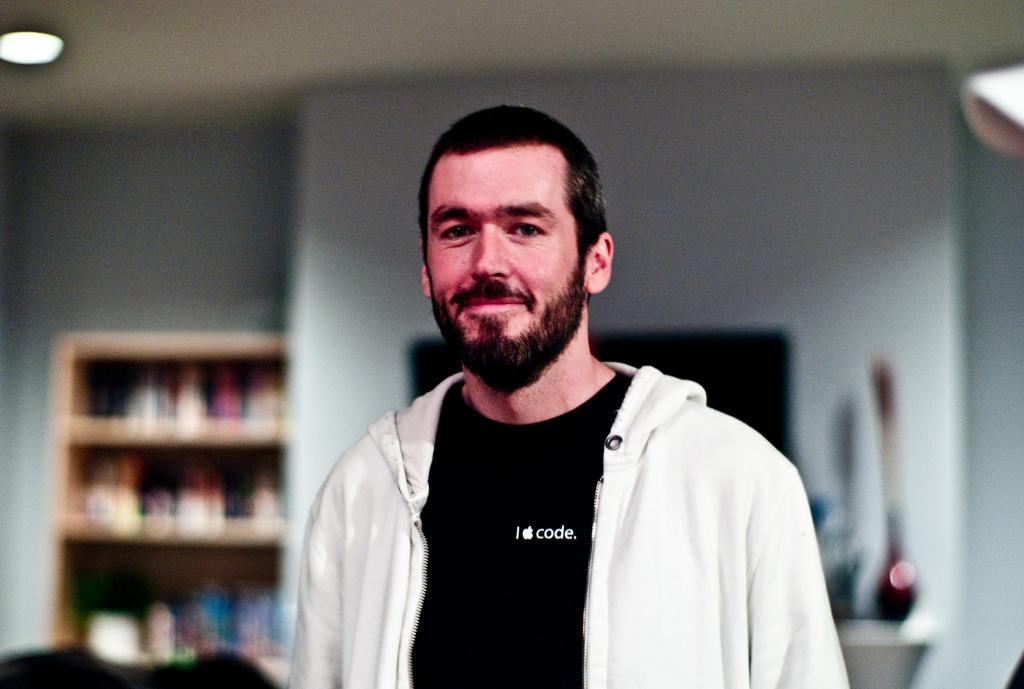<image>
Provide a brief description of the given image. A man in a black tshirt with the words "I code" on it 